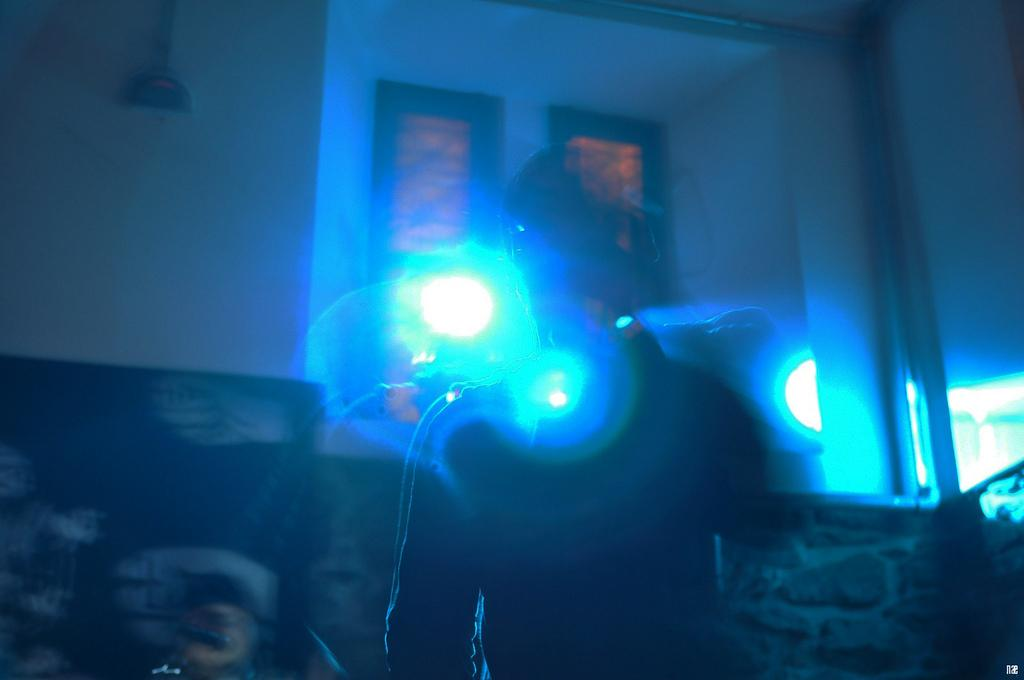What can be seen in the image? There is a person in the image. What is visible in the background of the image? There is a wall in the background of the image. Is there any opening in the wall visible in the image? Yes, there is a window in the image. What can be seen through the window? The background visible through the window is blurry. What type of fish can be seen swimming in the eggnog in the image? There is no fish or eggnog present in the image; it only features a person, a wall, a window, and a blurry background visible through the window. 